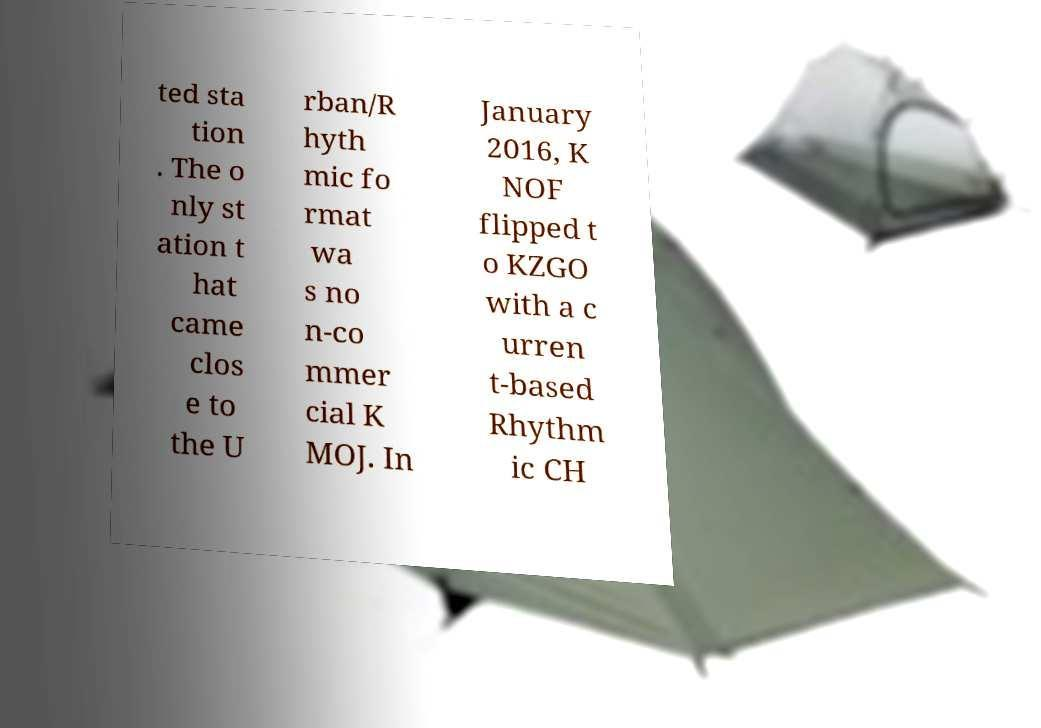What messages or text are displayed in this image? I need them in a readable, typed format. ted sta tion . The o nly st ation t hat came clos e to the U rban/R hyth mic fo rmat wa s no n-co mmer cial K MOJ. In January 2016, K NOF flipped t o KZGO with a c urren t-based Rhythm ic CH 